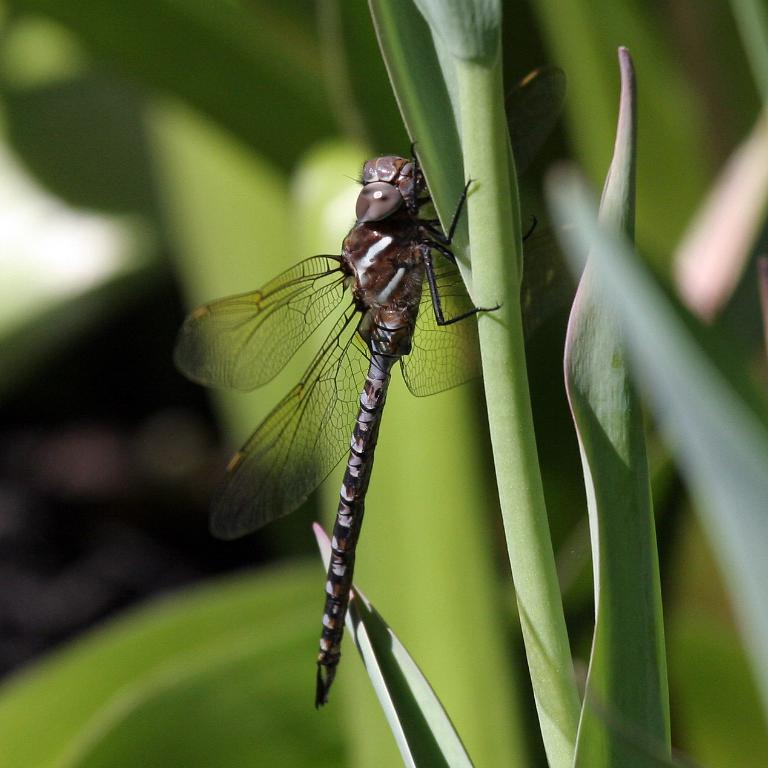What insect is present in the image? There is a dragonfly in the image. What is the dragonfly holding in the image? The dragonfly is holding the stem of a plant. What type of stamp can be seen on the door in the image? There is no stamp or door present in the image; it features a dragonfly holding the stem of a plant. 